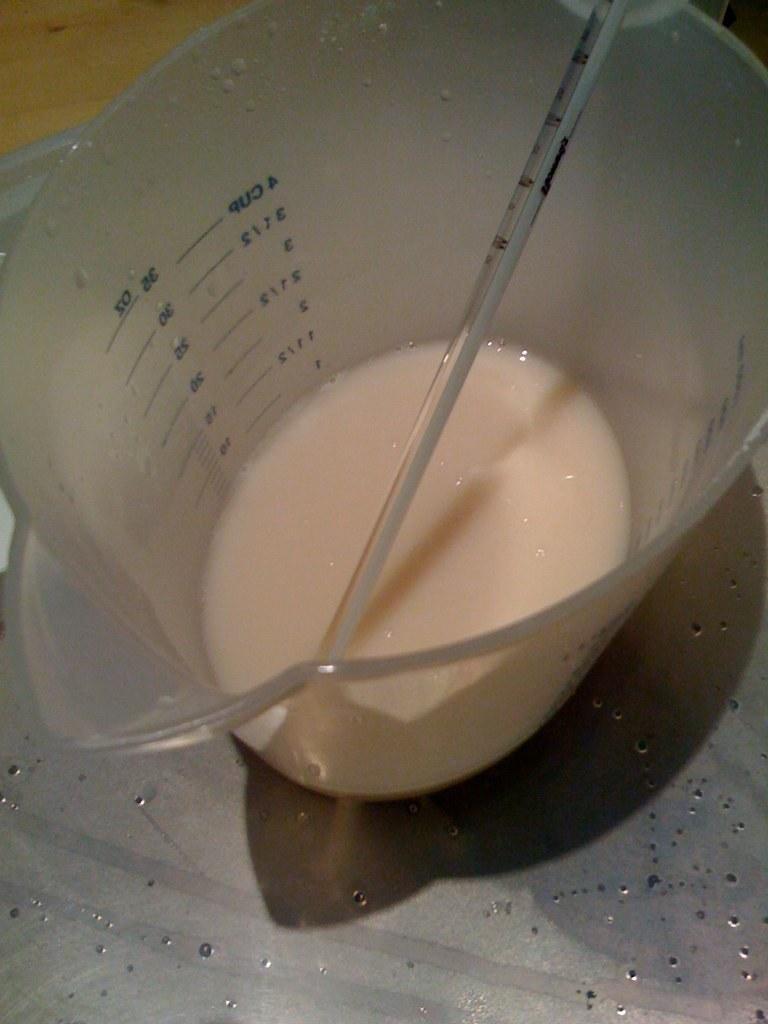How would you summarize this image in a sentence or two? In this image in the center there is one container, in that container there is some drink and one thermometer. At the bottom there is a table. 